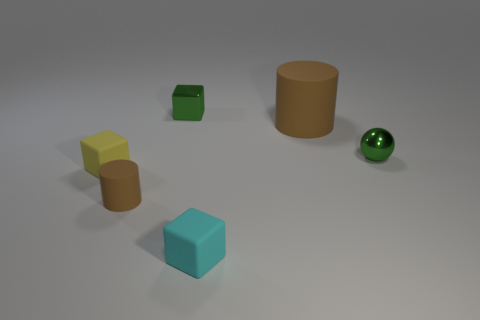Subtract all cyan blocks. How many blocks are left? 2 Add 2 green metallic blocks. How many objects exist? 8 Subtract 1 blocks. How many blocks are left? 2 Subtract all balls. How many objects are left? 5 Subtract all green blocks. How many blocks are left? 2 Add 3 tiny brown rubber spheres. How many tiny brown rubber spheres exist? 3 Subtract 0 gray cubes. How many objects are left? 6 Subtract all cyan spheres. Subtract all gray cylinders. How many spheres are left? 1 Subtract all rubber cylinders. Subtract all metal things. How many objects are left? 2 Add 5 cyan cubes. How many cyan cubes are left? 6 